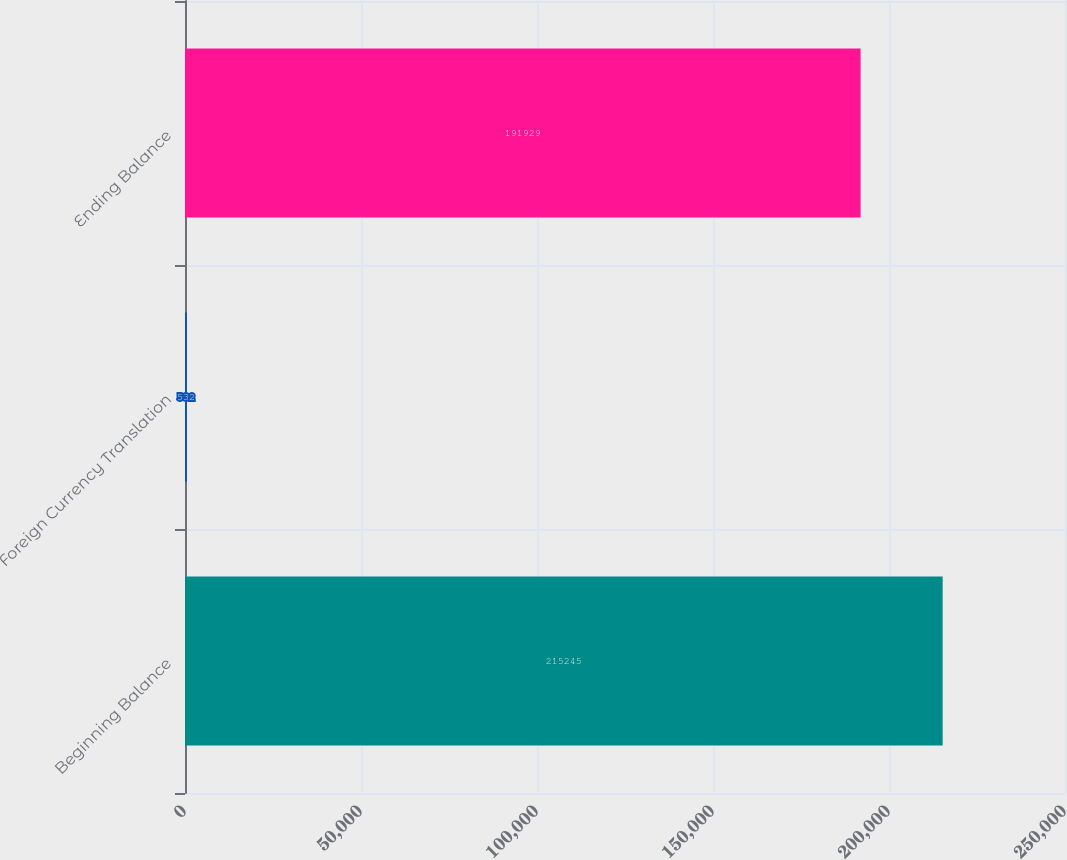Convert chart to OTSL. <chart><loc_0><loc_0><loc_500><loc_500><bar_chart><fcel>Beginning Balance<fcel>Foreign Currency Translation<fcel>Ending Balance<nl><fcel>215245<fcel>532<fcel>191929<nl></chart> 